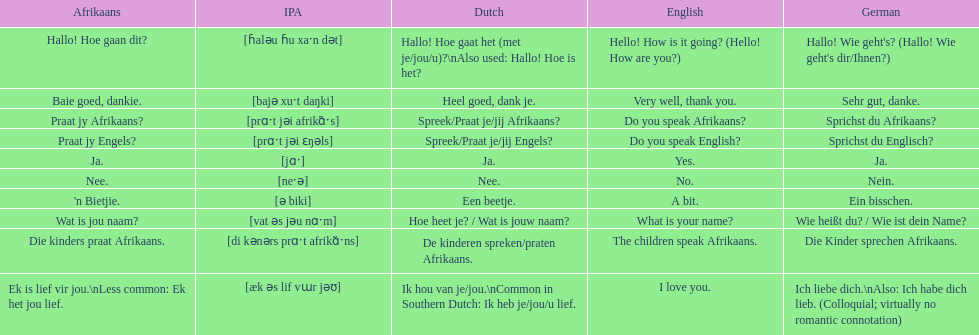Could you parse the entire table as a dict? {'header': ['Afrikaans', 'IPA', 'Dutch', 'English', 'German'], 'rows': [['Hallo! Hoe gaan dit?', '[ɦaləu ɦu xaˑn dət]', 'Hallo! Hoe gaat het (met je/jou/u)?\\nAlso used: Hallo! Hoe is het?', 'Hello! How is it going? (Hello! How are you?)', "Hallo! Wie geht's? (Hallo! Wie geht's dir/Ihnen?)"], ['Baie goed, dankie.', '[bajə xuˑt daŋki]', 'Heel goed, dank je.', 'Very well, thank you.', 'Sehr gut, danke.'], ['Praat jy Afrikaans?', '[prɑˑt jəi afrikɑ̃ˑs]', 'Spreek/Praat je/jij Afrikaans?', 'Do you speak Afrikaans?', 'Sprichst du Afrikaans?'], ['Praat jy Engels?', '[prɑˑt jəi ɛŋəls]', 'Spreek/Praat je/jij Engels?', 'Do you speak English?', 'Sprichst du Englisch?'], ['Ja.', '[jɑˑ]', 'Ja.', 'Yes.', 'Ja.'], ['Nee.', '[neˑə]', 'Nee.', 'No.', 'Nein.'], ["'n Bietjie.", '[ə biki]', 'Een beetje.', 'A bit.', 'Ein bisschen.'], ['Wat is jou naam?', '[vat əs jəu nɑˑm]', 'Hoe heet je? / Wat is jouw naam?', 'What is your name?', 'Wie heißt du? / Wie ist dein Name?'], ['Die kinders praat Afrikaans.', '[di kənərs prɑˑt afrikɑ̃ˑns]', 'De kinderen spreken/praten Afrikaans.', 'The children speak Afrikaans.', 'Die Kinder sprechen Afrikaans.'], ['Ek is lief vir jou.\\nLess common: Ek het jou lief.', '[æk əs lif vɯr jəʊ]', 'Ik hou van je/jou.\\nCommon in Southern Dutch: Ik heb je/jou/u lief.', 'I love you.', 'Ich liebe dich.\\nAlso: Ich habe dich lieb. (Colloquial; virtually no romantic connotation)']]} How do you say 'i love you' in afrikaans? Ek is lief vir jou. 